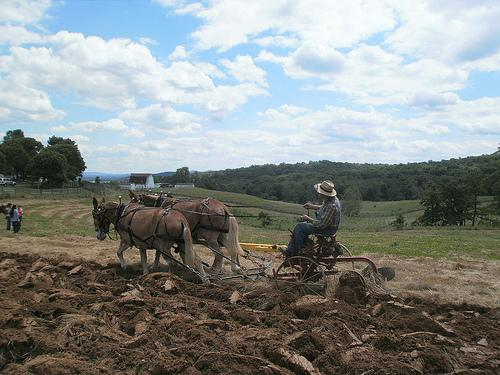Question: how many horses are there?
Choices:
A. 1.
B. 2.
C. 3.
D. 5.
Answer with the letter. Answer: B Question: who is pulling the plow?
Choices:
A. The farmer.
B. The tractor.
C. The mule team.
D. The horses.
Answer with the letter. Answer: D Question: what is the sky like?
Choices:
A. Cloudy.
B. Red.
C. Blue.
D. Black and gray.
Answer with the letter. Answer: A 